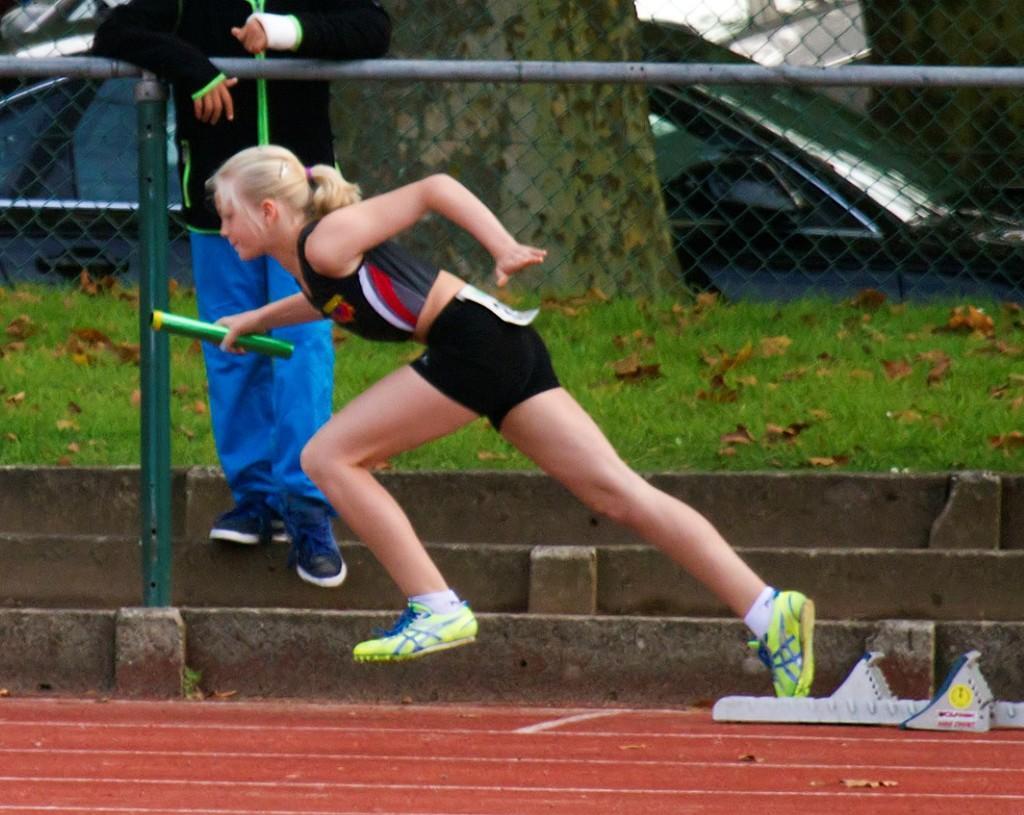Could you give a brief overview of what you see in this image? This picture might be taken inside a playground. In this image, in the middle, we can see a girl holding a stick on one hand is running. In the background, there is a man standing on the staircase, net fence, pole, cat, trees, at the bottom, we can see red color. 